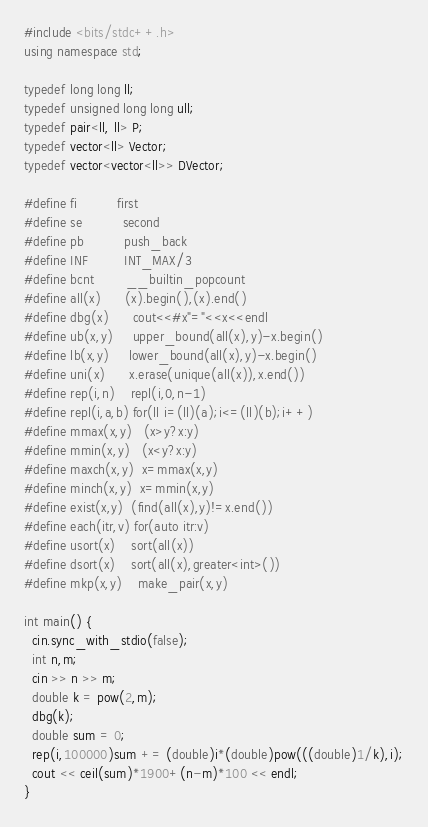<code> <loc_0><loc_0><loc_500><loc_500><_C++_>#include <bits/stdc++.h>
using namespace std;

typedef long long ll;
typedef unsigned long long ull;
typedef pair<ll, ll> P;
typedef vector<ll> Vector;
typedef vector<vector<ll>> DVector;

#define fi          first
#define se          second
#define pb          push_back
#define INF         INT_MAX/3
#define bcnt        __builtin_popcount
#define all(x)      (x).begin(),(x).end()
#define dbg(x)      cout<<#x"="<<x<<endl
#define ub(x,y)     upper_bound(all(x),y)-x.begin()
#define lb(x,y)     lower_bound(all(x),y)-x.begin()
#define uni(x)      x.erase(unique(all(x)),x.end())
#define rep(i,n)    repl(i,0,n-1)
#define repl(i,a,b) for(ll i=(ll)(a);i<=(ll)(b);i++)
#define mmax(x,y)   (x>y?x:y)
#define mmin(x,y)   (x<y?x:y)
#define maxch(x,y)  x=mmax(x,y)
#define minch(x,y)  x=mmin(x,y)
#define exist(x,y)  (find(all(x),y)!=x.end())
#define each(itr,v) for(auto itr:v)
#define usort(x)    sort(all(x))
#define dsort(x)    sort(all(x),greater<int>())
#define mkp(x,y)    make_pair(x,y)

int main() {
  cin.sync_with_stdio(false);
  int n,m;
  cin >> n >> m;
  double k = pow(2,m);
  dbg(k);
  double sum = 0;
  rep(i,100000)sum += (double)i*(double)pow(((double)1/k),i);
  cout << ceil(sum)*1900+(n-m)*100 << endl;
}
</code> 